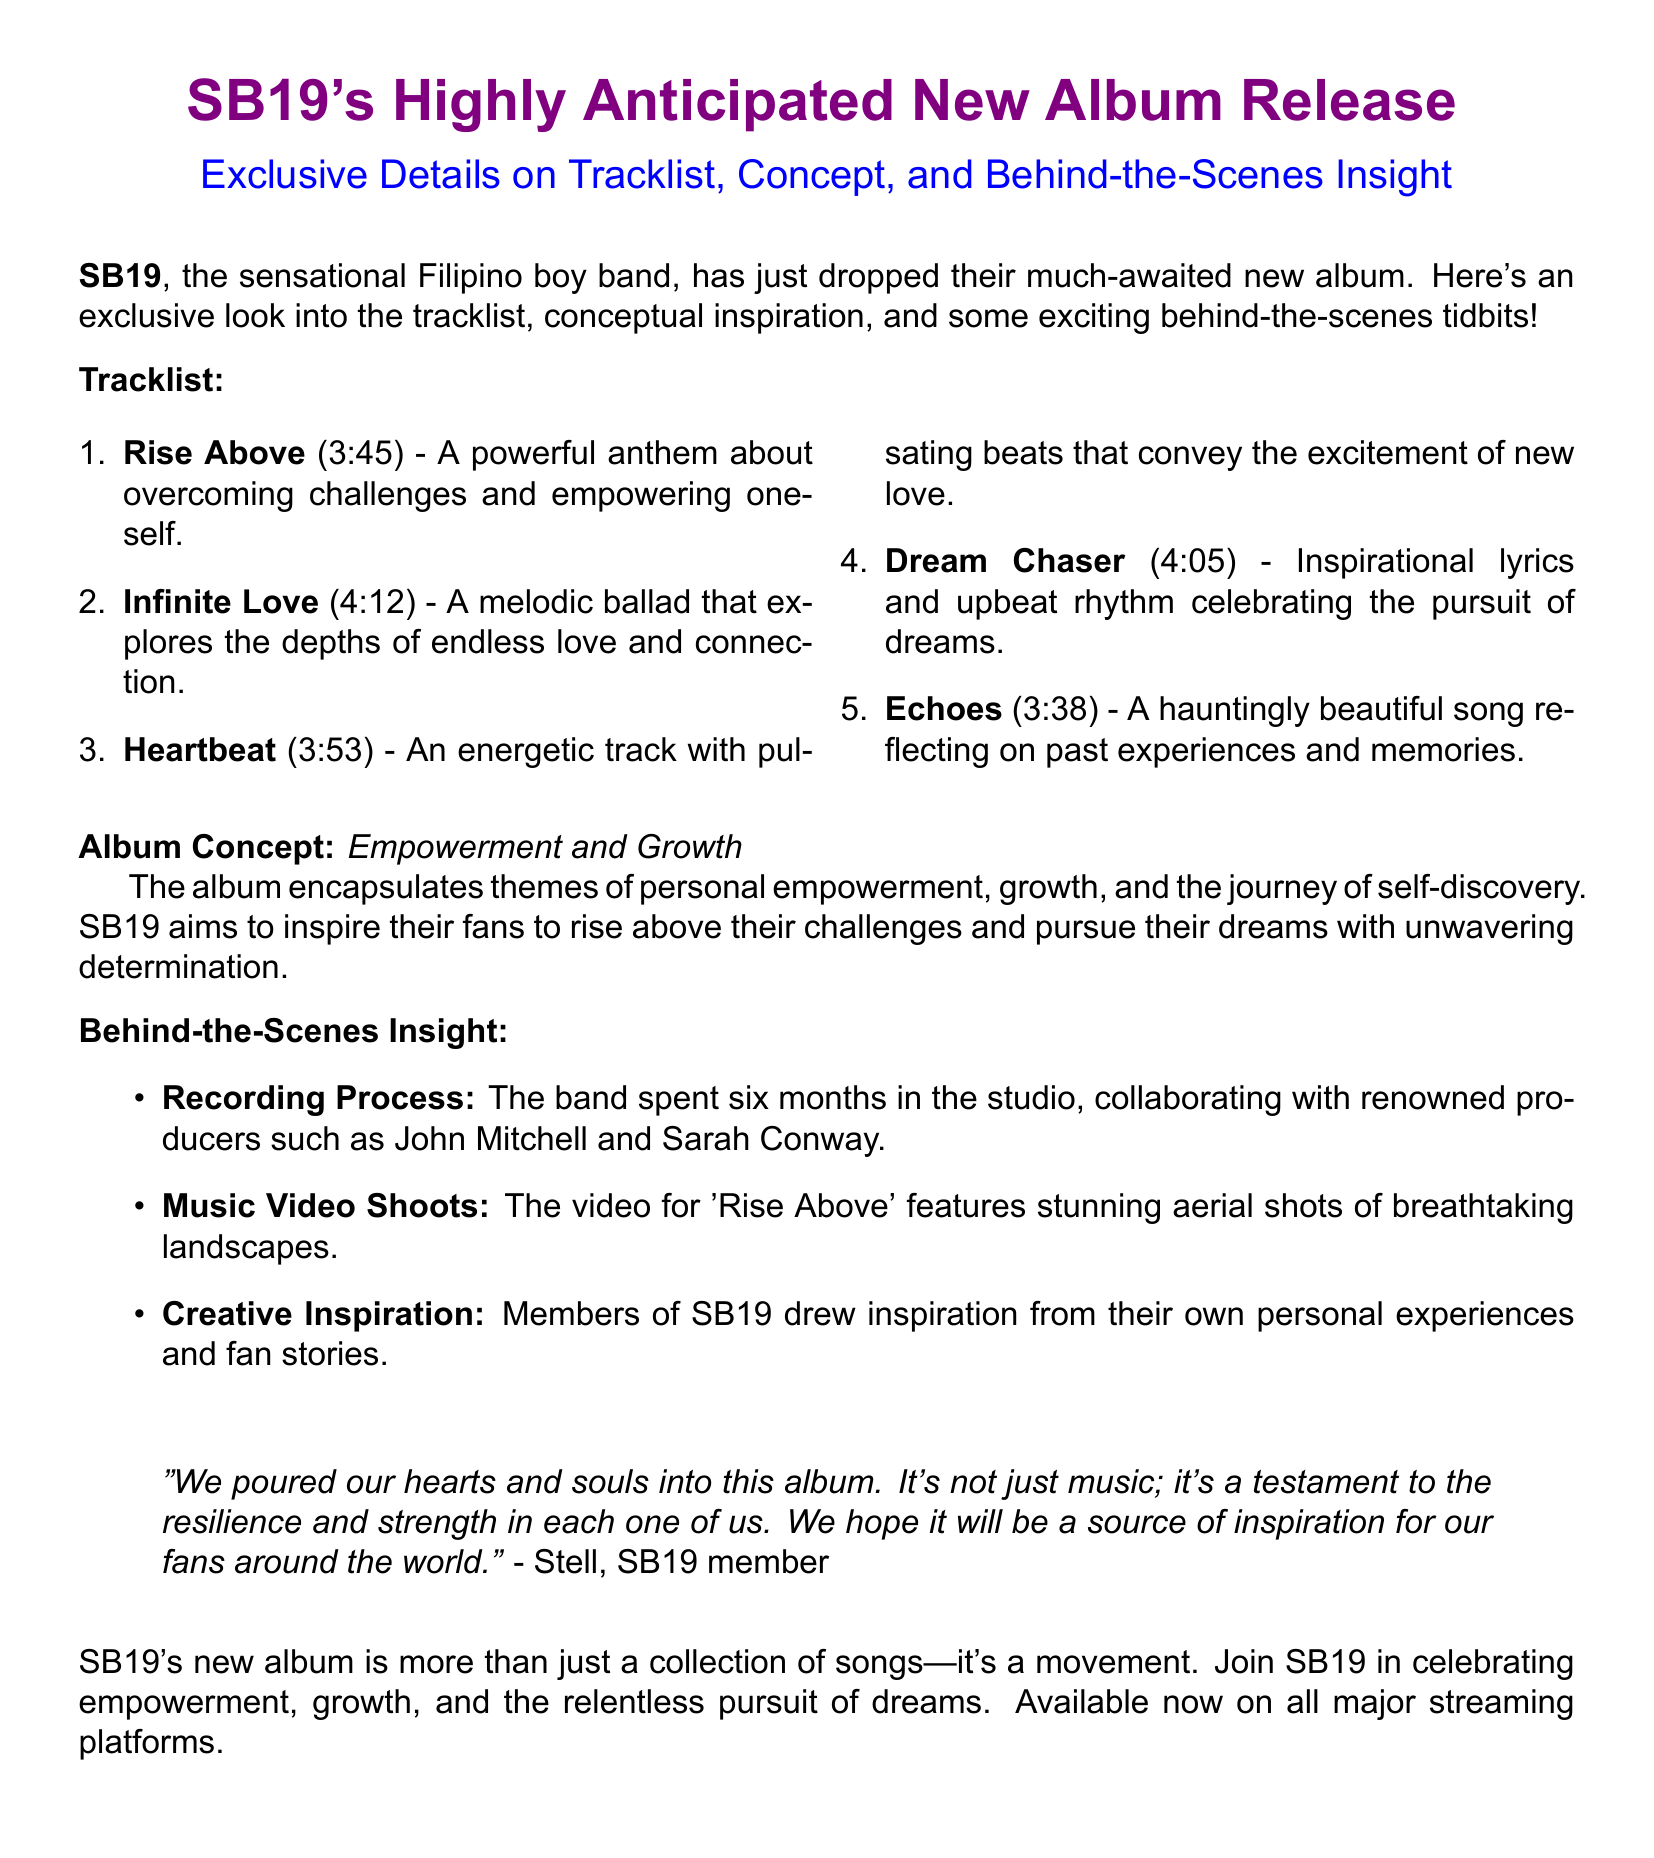What is the title of the album? The title of the album is mentioned at the beginning of the document.
Answer: SB19's Highly Anticipated New Album Release How many tracks are listed in the album? The document lists the number of tracks in the tracklist section.
Answer: 5 What is the duration of the track "Infinite Love"? The duration of this specific track is included in the tracklist.
Answer: 4:12 What is the main theme of the album? The main theme is derived from the album concept section of the document.
Answer: Empowerment and Growth Who collaborated with SB19 during the recording process? The names of the producers involved in the recording process are mentioned in the behind-the-scenes insight.
Answer: John Mitchell and Sarah Conway What is the total length of the track "Dream Chaser"? The total length is specified in the tracklist for this particular song.
Answer: 4:05 What does Stell say about the album? A quote by Stell expresses his feelings about the album and what it represents.
Answer: It's a testament to the resilience and strength in each one of us How long did SB19 spend in the studio for this album? The document specifies the amount of time the band spent recording the album.
Answer: Six months 